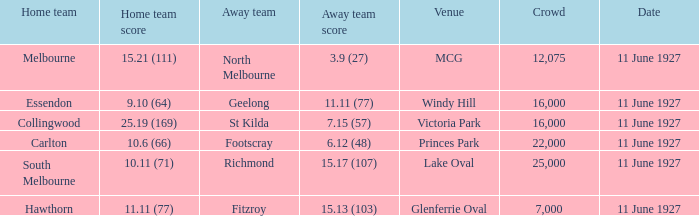I'm looking to parse the entire table for insights. Could you assist me with that? {'header': ['Home team', 'Home team score', 'Away team', 'Away team score', 'Venue', 'Crowd', 'Date'], 'rows': [['Melbourne', '15.21 (111)', 'North Melbourne', '3.9 (27)', 'MCG', '12,075', '11 June 1927'], ['Essendon', '9.10 (64)', 'Geelong', '11.11 (77)', 'Windy Hill', '16,000', '11 June 1927'], ['Collingwood', '25.19 (169)', 'St Kilda', '7.15 (57)', 'Victoria Park', '16,000', '11 June 1927'], ['Carlton', '10.6 (66)', 'Footscray', '6.12 (48)', 'Princes Park', '22,000', '11 June 1927'], ['South Melbourne', '10.11 (71)', 'Richmond', '15.17 (107)', 'Lake Oval', '25,000', '11 June 1927'], ['Hawthorn', '11.11 (77)', 'Fitzroy', '15.13 (103)', 'Glenferrie Oval', '7,000', '11 June 1927']]} When essendon was the home team, how many individuals were present in the crowd? 1.0. 